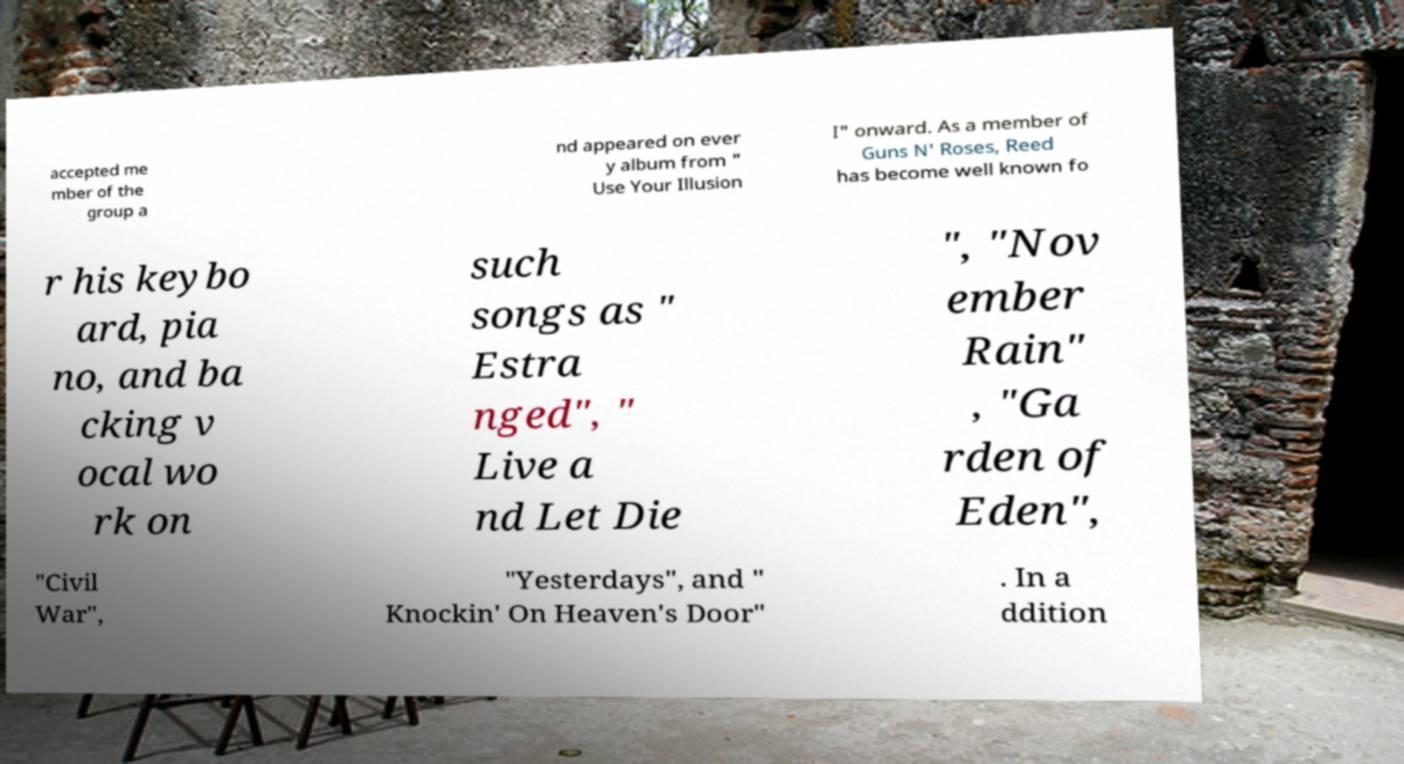Please identify and transcribe the text found in this image. accepted me mber of the group a nd appeared on ever y album from " Use Your Illusion I" onward. As a member of Guns N' Roses, Reed has become well known fo r his keybo ard, pia no, and ba cking v ocal wo rk on such songs as " Estra nged", " Live a nd Let Die ", "Nov ember Rain" , "Ga rden of Eden", "Civil War", "Yesterdays", and " Knockin' On Heaven's Door" . In a ddition 